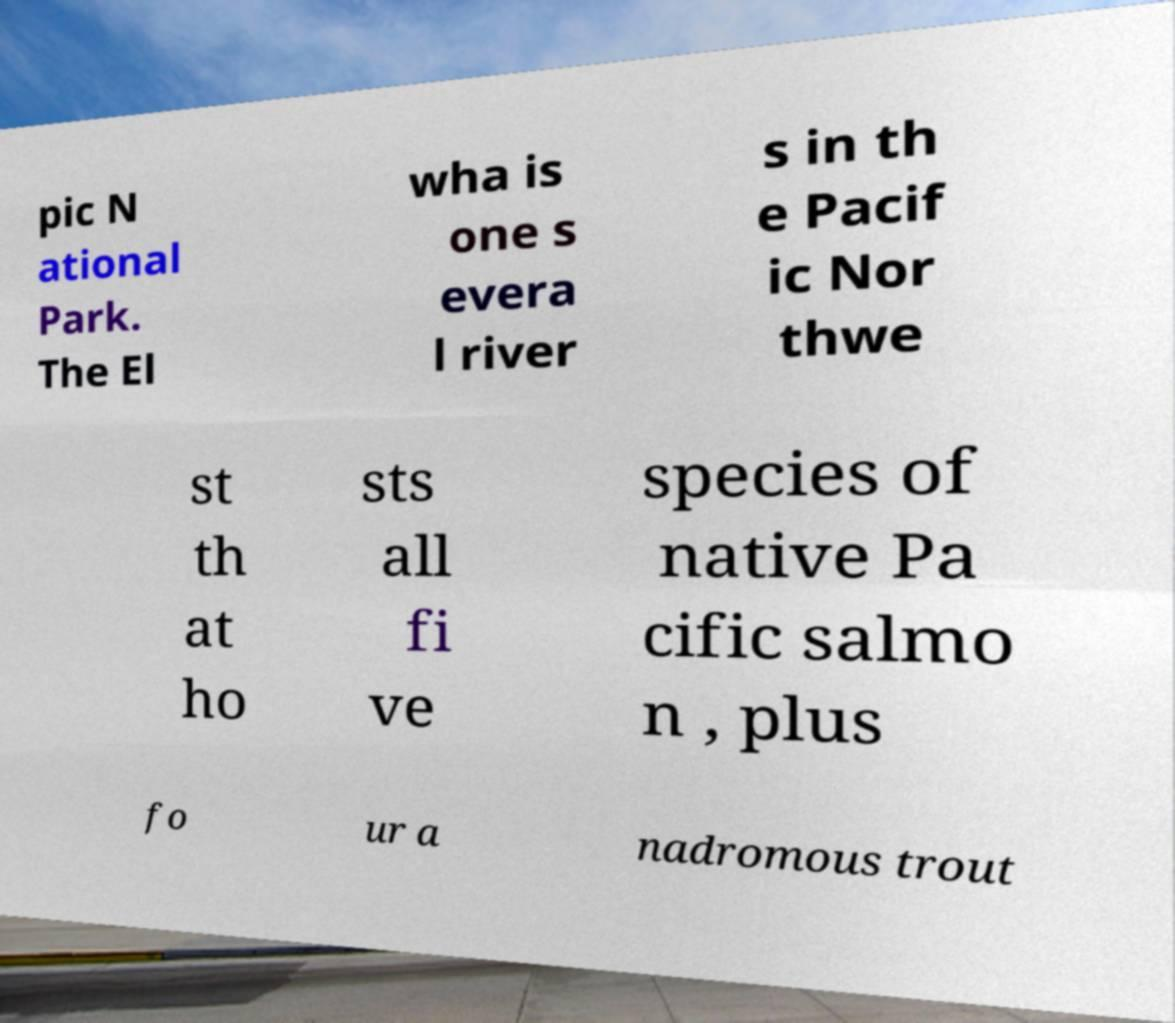I need the written content from this picture converted into text. Can you do that? pic N ational Park. The El wha is one s evera l river s in th e Pacif ic Nor thwe st th at ho sts all fi ve species of native Pa cific salmo n , plus fo ur a nadromous trout 